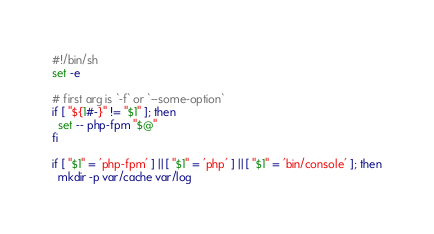<code> <loc_0><loc_0><loc_500><loc_500><_Bash_>#!/bin/sh
set -e

# first arg is `-f` or `--some-option`
if [ "${1#-}" != "$1" ]; then
  set -- php-fpm "$@"
fi

if [ "$1" = 'php-fpm' ] || [ "$1" = 'php' ] || [ "$1" = 'bin/console' ]; then
  mkdir -p var/cache var/log</code> 